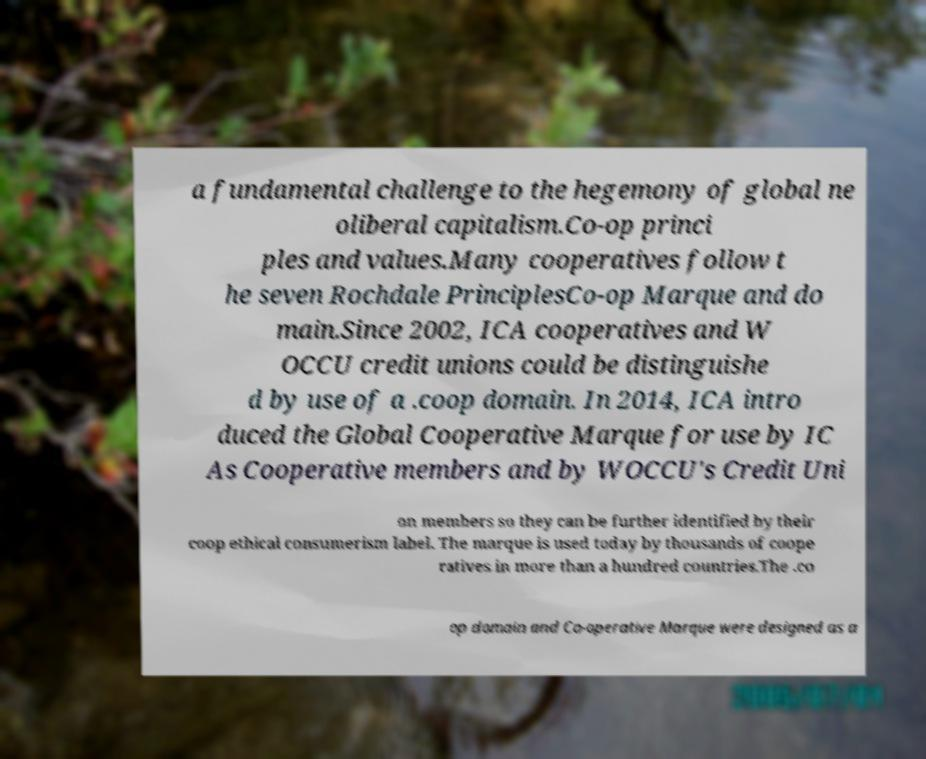Can you read and provide the text displayed in the image?This photo seems to have some interesting text. Can you extract and type it out for me? a fundamental challenge to the hegemony of global ne oliberal capitalism.Co-op princi ples and values.Many cooperatives follow t he seven Rochdale PrinciplesCo-op Marque and do main.Since 2002, ICA cooperatives and W OCCU credit unions could be distinguishe d by use of a .coop domain. In 2014, ICA intro duced the Global Cooperative Marque for use by IC As Cooperative members and by WOCCU's Credit Uni on members so they can be further identified by their coop ethical consumerism label. The marque is used today by thousands of coope ratives in more than a hundred countries.The .co op domain and Co-operative Marque were designed as a 